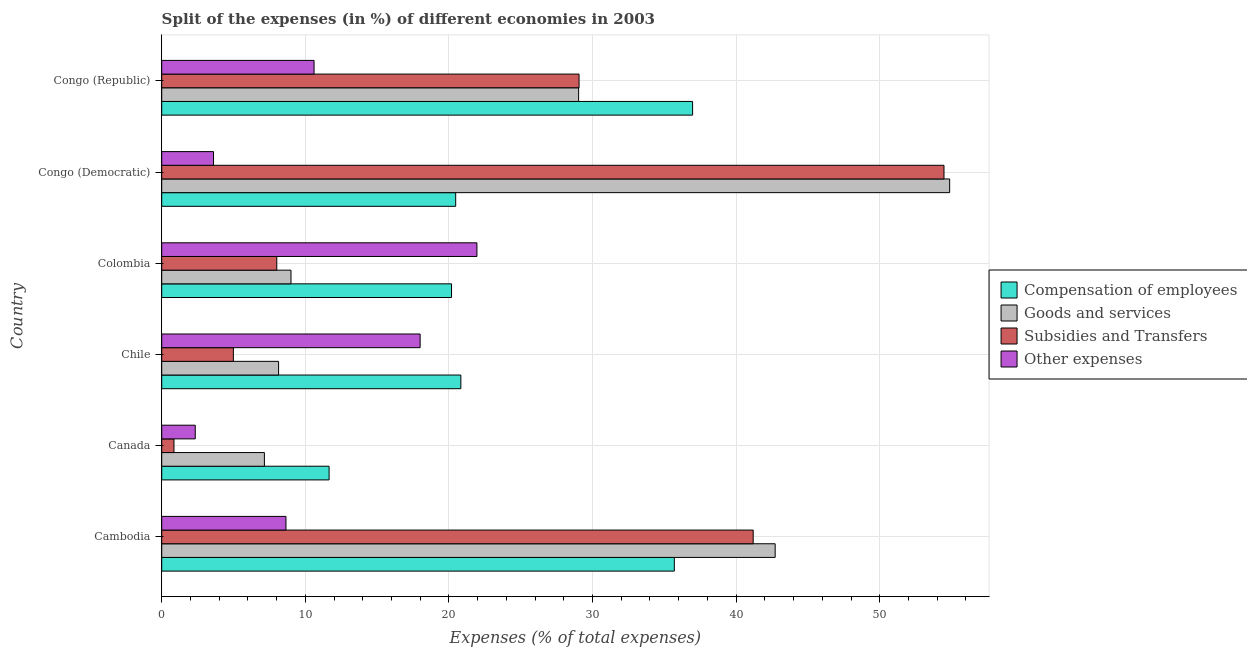How many different coloured bars are there?
Your answer should be compact. 4. How many groups of bars are there?
Give a very brief answer. 6. What is the label of the 4th group of bars from the top?
Make the answer very short. Chile. In how many cases, is the number of bars for a given country not equal to the number of legend labels?
Your answer should be compact. 0. What is the percentage of amount spent on compensation of employees in Colombia?
Keep it short and to the point. 20.18. Across all countries, what is the maximum percentage of amount spent on goods and services?
Make the answer very short. 54.87. Across all countries, what is the minimum percentage of amount spent on goods and services?
Make the answer very short. 7.15. In which country was the percentage of amount spent on subsidies maximum?
Offer a very short reply. Congo (Democratic). What is the total percentage of amount spent on goods and services in the graph?
Your answer should be compact. 150.91. What is the difference between the percentage of amount spent on goods and services in Cambodia and that in Canada?
Give a very brief answer. 35.57. What is the difference between the percentage of amount spent on subsidies in Canada and the percentage of amount spent on other expenses in Cambodia?
Your answer should be very brief. -7.8. What is the average percentage of amount spent on compensation of employees per country?
Make the answer very short. 24.3. What is the difference between the percentage of amount spent on other expenses and percentage of amount spent on subsidies in Cambodia?
Provide a short and direct response. -32.53. What is the ratio of the percentage of amount spent on goods and services in Chile to that in Congo (Democratic)?
Your answer should be very brief. 0.15. Is the percentage of amount spent on subsidies in Cambodia less than that in Canada?
Provide a short and direct response. No. Is the difference between the percentage of amount spent on subsidies in Chile and Congo (Democratic) greater than the difference between the percentage of amount spent on goods and services in Chile and Congo (Democratic)?
Offer a very short reply. No. What is the difference between the highest and the second highest percentage of amount spent on goods and services?
Make the answer very short. 12.15. What is the difference between the highest and the lowest percentage of amount spent on subsidies?
Your response must be concise. 53.62. In how many countries, is the percentage of amount spent on compensation of employees greater than the average percentage of amount spent on compensation of employees taken over all countries?
Give a very brief answer. 2. What does the 3rd bar from the top in Canada represents?
Make the answer very short. Goods and services. What does the 1st bar from the bottom in Cambodia represents?
Ensure brevity in your answer.  Compensation of employees. Is it the case that in every country, the sum of the percentage of amount spent on compensation of employees and percentage of amount spent on goods and services is greater than the percentage of amount spent on subsidies?
Give a very brief answer. Yes. How many countries are there in the graph?
Offer a very short reply. 6. Are the values on the major ticks of X-axis written in scientific E-notation?
Your answer should be compact. No. Does the graph contain any zero values?
Ensure brevity in your answer.  No. Does the graph contain grids?
Offer a very short reply. Yes. Where does the legend appear in the graph?
Offer a very short reply. Center right. How are the legend labels stacked?
Your answer should be compact. Vertical. What is the title of the graph?
Keep it short and to the point. Split of the expenses (in %) of different economies in 2003. What is the label or title of the X-axis?
Keep it short and to the point. Expenses (% of total expenses). What is the label or title of the Y-axis?
Offer a very short reply. Country. What is the Expenses (% of total expenses) in Compensation of employees in Cambodia?
Give a very brief answer. 35.7. What is the Expenses (% of total expenses) in Goods and services in Cambodia?
Your answer should be compact. 42.72. What is the Expenses (% of total expenses) in Subsidies and Transfers in Cambodia?
Keep it short and to the point. 41.19. What is the Expenses (% of total expenses) of Other expenses in Cambodia?
Ensure brevity in your answer.  8.65. What is the Expenses (% of total expenses) of Compensation of employees in Canada?
Your response must be concise. 11.66. What is the Expenses (% of total expenses) in Goods and services in Canada?
Offer a terse response. 7.15. What is the Expenses (% of total expenses) in Subsidies and Transfers in Canada?
Your response must be concise. 0.85. What is the Expenses (% of total expenses) of Other expenses in Canada?
Give a very brief answer. 2.34. What is the Expenses (% of total expenses) in Compensation of employees in Chile?
Make the answer very short. 20.83. What is the Expenses (% of total expenses) in Goods and services in Chile?
Ensure brevity in your answer.  8.14. What is the Expenses (% of total expenses) in Subsidies and Transfers in Chile?
Keep it short and to the point. 4.99. What is the Expenses (% of total expenses) of Other expenses in Chile?
Your response must be concise. 17.99. What is the Expenses (% of total expenses) of Compensation of employees in Colombia?
Offer a very short reply. 20.18. What is the Expenses (% of total expenses) of Goods and services in Colombia?
Make the answer very short. 9. What is the Expenses (% of total expenses) in Subsidies and Transfers in Colombia?
Your response must be concise. 8.01. What is the Expenses (% of total expenses) of Other expenses in Colombia?
Keep it short and to the point. 21.95. What is the Expenses (% of total expenses) of Compensation of employees in Congo (Democratic)?
Offer a terse response. 20.47. What is the Expenses (% of total expenses) in Goods and services in Congo (Democratic)?
Make the answer very short. 54.87. What is the Expenses (% of total expenses) of Subsidies and Transfers in Congo (Democratic)?
Ensure brevity in your answer.  54.47. What is the Expenses (% of total expenses) of Other expenses in Congo (Democratic)?
Provide a succinct answer. 3.61. What is the Expenses (% of total expenses) in Compensation of employees in Congo (Republic)?
Provide a short and direct response. 36.97. What is the Expenses (% of total expenses) in Goods and services in Congo (Republic)?
Offer a terse response. 29.03. What is the Expenses (% of total expenses) in Subsidies and Transfers in Congo (Republic)?
Make the answer very short. 29.06. What is the Expenses (% of total expenses) of Other expenses in Congo (Republic)?
Provide a succinct answer. 10.61. Across all countries, what is the maximum Expenses (% of total expenses) in Compensation of employees?
Your answer should be very brief. 36.97. Across all countries, what is the maximum Expenses (% of total expenses) of Goods and services?
Offer a very short reply. 54.87. Across all countries, what is the maximum Expenses (% of total expenses) in Subsidies and Transfers?
Offer a terse response. 54.47. Across all countries, what is the maximum Expenses (% of total expenses) in Other expenses?
Make the answer very short. 21.95. Across all countries, what is the minimum Expenses (% of total expenses) of Compensation of employees?
Provide a short and direct response. 11.66. Across all countries, what is the minimum Expenses (% of total expenses) in Goods and services?
Ensure brevity in your answer.  7.15. Across all countries, what is the minimum Expenses (% of total expenses) in Subsidies and Transfers?
Provide a short and direct response. 0.85. Across all countries, what is the minimum Expenses (% of total expenses) of Other expenses?
Make the answer very short. 2.34. What is the total Expenses (% of total expenses) in Compensation of employees in the graph?
Provide a succinct answer. 145.8. What is the total Expenses (% of total expenses) of Goods and services in the graph?
Provide a short and direct response. 150.91. What is the total Expenses (% of total expenses) of Subsidies and Transfers in the graph?
Offer a very short reply. 138.58. What is the total Expenses (% of total expenses) in Other expenses in the graph?
Your answer should be compact. 65.15. What is the difference between the Expenses (% of total expenses) of Compensation of employees in Cambodia and that in Canada?
Offer a terse response. 24.04. What is the difference between the Expenses (% of total expenses) of Goods and services in Cambodia and that in Canada?
Keep it short and to the point. 35.57. What is the difference between the Expenses (% of total expenses) in Subsidies and Transfers in Cambodia and that in Canada?
Offer a terse response. 40.33. What is the difference between the Expenses (% of total expenses) of Other expenses in Cambodia and that in Canada?
Offer a terse response. 6.32. What is the difference between the Expenses (% of total expenses) in Compensation of employees in Cambodia and that in Chile?
Make the answer very short. 14.87. What is the difference between the Expenses (% of total expenses) in Goods and services in Cambodia and that in Chile?
Offer a very short reply. 34.58. What is the difference between the Expenses (% of total expenses) of Subsidies and Transfers in Cambodia and that in Chile?
Offer a terse response. 36.2. What is the difference between the Expenses (% of total expenses) in Other expenses in Cambodia and that in Chile?
Give a very brief answer. -9.34. What is the difference between the Expenses (% of total expenses) of Compensation of employees in Cambodia and that in Colombia?
Provide a succinct answer. 15.51. What is the difference between the Expenses (% of total expenses) of Goods and services in Cambodia and that in Colombia?
Make the answer very short. 33.72. What is the difference between the Expenses (% of total expenses) in Subsidies and Transfers in Cambodia and that in Colombia?
Offer a very short reply. 33.17. What is the difference between the Expenses (% of total expenses) of Other expenses in Cambodia and that in Colombia?
Your response must be concise. -13.3. What is the difference between the Expenses (% of total expenses) of Compensation of employees in Cambodia and that in Congo (Democratic)?
Ensure brevity in your answer.  15.22. What is the difference between the Expenses (% of total expenses) in Goods and services in Cambodia and that in Congo (Democratic)?
Offer a very short reply. -12.15. What is the difference between the Expenses (% of total expenses) in Subsidies and Transfers in Cambodia and that in Congo (Democratic)?
Provide a succinct answer. -13.29. What is the difference between the Expenses (% of total expenses) in Other expenses in Cambodia and that in Congo (Democratic)?
Make the answer very short. 5.04. What is the difference between the Expenses (% of total expenses) in Compensation of employees in Cambodia and that in Congo (Republic)?
Your answer should be very brief. -1.27. What is the difference between the Expenses (% of total expenses) of Goods and services in Cambodia and that in Congo (Republic)?
Provide a short and direct response. 13.69. What is the difference between the Expenses (% of total expenses) in Subsidies and Transfers in Cambodia and that in Congo (Republic)?
Your answer should be compact. 12.13. What is the difference between the Expenses (% of total expenses) in Other expenses in Cambodia and that in Congo (Republic)?
Offer a terse response. -1.96. What is the difference between the Expenses (% of total expenses) of Compensation of employees in Canada and that in Chile?
Provide a short and direct response. -9.17. What is the difference between the Expenses (% of total expenses) in Goods and services in Canada and that in Chile?
Your answer should be very brief. -0.99. What is the difference between the Expenses (% of total expenses) of Subsidies and Transfers in Canada and that in Chile?
Your answer should be very brief. -4.14. What is the difference between the Expenses (% of total expenses) in Other expenses in Canada and that in Chile?
Offer a very short reply. -15.66. What is the difference between the Expenses (% of total expenses) of Compensation of employees in Canada and that in Colombia?
Your answer should be very brief. -8.53. What is the difference between the Expenses (% of total expenses) in Goods and services in Canada and that in Colombia?
Provide a short and direct response. -1.85. What is the difference between the Expenses (% of total expenses) in Subsidies and Transfers in Canada and that in Colombia?
Provide a short and direct response. -7.16. What is the difference between the Expenses (% of total expenses) of Other expenses in Canada and that in Colombia?
Provide a short and direct response. -19.61. What is the difference between the Expenses (% of total expenses) of Compensation of employees in Canada and that in Congo (Democratic)?
Provide a short and direct response. -8.82. What is the difference between the Expenses (% of total expenses) in Goods and services in Canada and that in Congo (Democratic)?
Give a very brief answer. -47.72. What is the difference between the Expenses (% of total expenses) of Subsidies and Transfers in Canada and that in Congo (Democratic)?
Make the answer very short. -53.62. What is the difference between the Expenses (% of total expenses) in Other expenses in Canada and that in Congo (Democratic)?
Keep it short and to the point. -1.27. What is the difference between the Expenses (% of total expenses) of Compensation of employees in Canada and that in Congo (Republic)?
Keep it short and to the point. -25.31. What is the difference between the Expenses (% of total expenses) in Goods and services in Canada and that in Congo (Republic)?
Offer a terse response. -21.88. What is the difference between the Expenses (% of total expenses) of Subsidies and Transfers in Canada and that in Congo (Republic)?
Provide a succinct answer. -28.21. What is the difference between the Expenses (% of total expenses) in Other expenses in Canada and that in Congo (Republic)?
Provide a short and direct response. -8.27. What is the difference between the Expenses (% of total expenses) of Compensation of employees in Chile and that in Colombia?
Your answer should be compact. 0.65. What is the difference between the Expenses (% of total expenses) of Goods and services in Chile and that in Colombia?
Give a very brief answer. -0.86. What is the difference between the Expenses (% of total expenses) of Subsidies and Transfers in Chile and that in Colombia?
Your answer should be very brief. -3.02. What is the difference between the Expenses (% of total expenses) of Other expenses in Chile and that in Colombia?
Give a very brief answer. -3.96. What is the difference between the Expenses (% of total expenses) in Compensation of employees in Chile and that in Congo (Democratic)?
Provide a short and direct response. 0.36. What is the difference between the Expenses (% of total expenses) of Goods and services in Chile and that in Congo (Democratic)?
Offer a very short reply. -46.73. What is the difference between the Expenses (% of total expenses) in Subsidies and Transfers in Chile and that in Congo (Democratic)?
Provide a short and direct response. -49.49. What is the difference between the Expenses (% of total expenses) in Other expenses in Chile and that in Congo (Democratic)?
Offer a very short reply. 14.39. What is the difference between the Expenses (% of total expenses) in Compensation of employees in Chile and that in Congo (Republic)?
Make the answer very short. -16.14. What is the difference between the Expenses (% of total expenses) in Goods and services in Chile and that in Congo (Republic)?
Make the answer very short. -20.89. What is the difference between the Expenses (% of total expenses) in Subsidies and Transfers in Chile and that in Congo (Republic)?
Your response must be concise. -24.07. What is the difference between the Expenses (% of total expenses) of Other expenses in Chile and that in Congo (Republic)?
Keep it short and to the point. 7.39. What is the difference between the Expenses (% of total expenses) in Compensation of employees in Colombia and that in Congo (Democratic)?
Keep it short and to the point. -0.29. What is the difference between the Expenses (% of total expenses) in Goods and services in Colombia and that in Congo (Democratic)?
Provide a short and direct response. -45.87. What is the difference between the Expenses (% of total expenses) of Subsidies and Transfers in Colombia and that in Congo (Democratic)?
Your answer should be very brief. -46.46. What is the difference between the Expenses (% of total expenses) of Other expenses in Colombia and that in Congo (Democratic)?
Provide a short and direct response. 18.34. What is the difference between the Expenses (% of total expenses) in Compensation of employees in Colombia and that in Congo (Republic)?
Provide a succinct answer. -16.79. What is the difference between the Expenses (% of total expenses) of Goods and services in Colombia and that in Congo (Republic)?
Your response must be concise. -20.03. What is the difference between the Expenses (% of total expenses) of Subsidies and Transfers in Colombia and that in Congo (Republic)?
Give a very brief answer. -21.05. What is the difference between the Expenses (% of total expenses) of Other expenses in Colombia and that in Congo (Republic)?
Provide a succinct answer. 11.34. What is the difference between the Expenses (% of total expenses) in Compensation of employees in Congo (Democratic) and that in Congo (Republic)?
Provide a short and direct response. -16.5. What is the difference between the Expenses (% of total expenses) in Goods and services in Congo (Democratic) and that in Congo (Republic)?
Your answer should be very brief. 25.84. What is the difference between the Expenses (% of total expenses) in Subsidies and Transfers in Congo (Democratic) and that in Congo (Republic)?
Your answer should be very brief. 25.41. What is the difference between the Expenses (% of total expenses) of Other expenses in Congo (Democratic) and that in Congo (Republic)?
Keep it short and to the point. -7. What is the difference between the Expenses (% of total expenses) in Compensation of employees in Cambodia and the Expenses (% of total expenses) in Goods and services in Canada?
Offer a terse response. 28.54. What is the difference between the Expenses (% of total expenses) of Compensation of employees in Cambodia and the Expenses (% of total expenses) of Subsidies and Transfers in Canada?
Your answer should be very brief. 34.84. What is the difference between the Expenses (% of total expenses) in Compensation of employees in Cambodia and the Expenses (% of total expenses) in Other expenses in Canada?
Offer a terse response. 33.36. What is the difference between the Expenses (% of total expenses) in Goods and services in Cambodia and the Expenses (% of total expenses) in Subsidies and Transfers in Canada?
Make the answer very short. 41.86. What is the difference between the Expenses (% of total expenses) of Goods and services in Cambodia and the Expenses (% of total expenses) of Other expenses in Canada?
Offer a very short reply. 40.38. What is the difference between the Expenses (% of total expenses) in Subsidies and Transfers in Cambodia and the Expenses (% of total expenses) in Other expenses in Canada?
Keep it short and to the point. 38.85. What is the difference between the Expenses (% of total expenses) of Compensation of employees in Cambodia and the Expenses (% of total expenses) of Goods and services in Chile?
Your response must be concise. 27.56. What is the difference between the Expenses (% of total expenses) in Compensation of employees in Cambodia and the Expenses (% of total expenses) in Subsidies and Transfers in Chile?
Make the answer very short. 30.71. What is the difference between the Expenses (% of total expenses) of Compensation of employees in Cambodia and the Expenses (% of total expenses) of Other expenses in Chile?
Offer a very short reply. 17.7. What is the difference between the Expenses (% of total expenses) in Goods and services in Cambodia and the Expenses (% of total expenses) in Subsidies and Transfers in Chile?
Your answer should be very brief. 37.73. What is the difference between the Expenses (% of total expenses) in Goods and services in Cambodia and the Expenses (% of total expenses) in Other expenses in Chile?
Your answer should be very brief. 24.72. What is the difference between the Expenses (% of total expenses) of Subsidies and Transfers in Cambodia and the Expenses (% of total expenses) of Other expenses in Chile?
Keep it short and to the point. 23.19. What is the difference between the Expenses (% of total expenses) of Compensation of employees in Cambodia and the Expenses (% of total expenses) of Goods and services in Colombia?
Give a very brief answer. 26.69. What is the difference between the Expenses (% of total expenses) in Compensation of employees in Cambodia and the Expenses (% of total expenses) in Subsidies and Transfers in Colombia?
Give a very brief answer. 27.68. What is the difference between the Expenses (% of total expenses) in Compensation of employees in Cambodia and the Expenses (% of total expenses) in Other expenses in Colombia?
Make the answer very short. 13.75. What is the difference between the Expenses (% of total expenses) in Goods and services in Cambodia and the Expenses (% of total expenses) in Subsidies and Transfers in Colombia?
Your response must be concise. 34.71. What is the difference between the Expenses (% of total expenses) of Goods and services in Cambodia and the Expenses (% of total expenses) of Other expenses in Colombia?
Give a very brief answer. 20.77. What is the difference between the Expenses (% of total expenses) in Subsidies and Transfers in Cambodia and the Expenses (% of total expenses) in Other expenses in Colombia?
Your answer should be compact. 19.24. What is the difference between the Expenses (% of total expenses) of Compensation of employees in Cambodia and the Expenses (% of total expenses) of Goods and services in Congo (Democratic)?
Give a very brief answer. -19.17. What is the difference between the Expenses (% of total expenses) of Compensation of employees in Cambodia and the Expenses (% of total expenses) of Subsidies and Transfers in Congo (Democratic)?
Ensure brevity in your answer.  -18.78. What is the difference between the Expenses (% of total expenses) in Compensation of employees in Cambodia and the Expenses (% of total expenses) in Other expenses in Congo (Democratic)?
Offer a terse response. 32.09. What is the difference between the Expenses (% of total expenses) in Goods and services in Cambodia and the Expenses (% of total expenses) in Subsidies and Transfers in Congo (Democratic)?
Offer a terse response. -11.76. What is the difference between the Expenses (% of total expenses) of Goods and services in Cambodia and the Expenses (% of total expenses) of Other expenses in Congo (Democratic)?
Provide a short and direct response. 39.11. What is the difference between the Expenses (% of total expenses) of Subsidies and Transfers in Cambodia and the Expenses (% of total expenses) of Other expenses in Congo (Democratic)?
Your response must be concise. 37.58. What is the difference between the Expenses (% of total expenses) of Compensation of employees in Cambodia and the Expenses (% of total expenses) of Goods and services in Congo (Republic)?
Offer a terse response. 6.66. What is the difference between the Expenses (% of total expenses) in Compensation of employees in Cambodia and the Expenses (% of total expenses) in Subsidies and Transfers in Congo (Republic)?
Provide a short and direct response. 6.63. What is the difference between the Expenses (% of total expenses) of Compensation of employees in Cambodia and the Expenses (% of total expenses) of Other expenses in Congo (Republic)?
Ensure brevity in your answer.  25.09. What is the difference between the Expenses (% of total expenses) in Goods and services in Cambodia and the Expenses (% of total expenses) in Subsidies and Transfers in Congo (Republic)?
Your response must be concise. 13.66. What is the difference between the Expenses (% of total expenses) of Goods and services in Cambodia and the Expenses (% of total expenses) of Other expenses in Congo (Republic)?
Your answer should be compact. 32.11. What is the difference between the Expenses (% of total expenses) of Subsidies and Transfers in Cambodia and the Expenses (% of total expenses) of Other expenses in Congo (Republic)?
Make the answer very short. 30.58. What is the difference between the Expenses (% of total expenses) of Compensation of employees in Canada and the Expenses (% of total expenses) of Goods and services in Chile?
Give a very brief answer. 3.52. What is the difference between the Expenses (% of total expenses) of Compensation of employees in Canada and the Expenses (% of total expenses) of Subsidies and Transfers in Chile?
Ensure brevity in your answer.  6.67. What is the difference between the Expenses (% of total expenses) in Compensation of employees in Canada and the Expenses (% of total expenses) in Other expenses in Chile?
Give a very brief answer. -6.34. What is the difference between the Expenses (% of total expenses) of Goods and services in Canada and the Expenses (% of total expenses) of Subsidies and Transfers in Chile?
Offer a terse response. 2.16. What is the difference between the Expenses (% of total expenses) in Goods and services in Canada and the Expenses (% of total expenses) in Other expenses in Chile?
Ensure brevity in your answer.  -10.84. What is the difference between the Expenses (% of total expenses) of Subsidies and Transfers in Canada and the Expenses (% of total expenses) of Other expenses in Chile?
Keep it short and to the point. -17.14. What is the difference between the Expenses (% of total expenses) of Compensation of employees in Canada and the Expenses (% of total expenses) of Goods and services in Colombia?
Provide a succinct answer. 2.65. What is the difference between the Expenses (% of total expenses) in Compensation of employees in Canada and the Expenses (% of total expenses) in Subsidies and Transfers in Colombia?
Keep it short and to the point. 3.64. What is the difference between the Expenses (% of total expenses) of Compensation of employees in Canada and the Expenses (% of total expenses) of Other expenses in Colombia?
Provide a succinct answer. -10.29. What is the difference between the Expenses (% of total expenses) in Goods and services in Canada and the Expenses (% of total expenses) in Subsidies and Transfers in Colombia?
Provide a succinct answer. -0.86. What is the difference between the Expenses (% of total expenses) of Goods and services in Canada and the Expenses (% of total expenses) of Other expenses in Colombia?
Give a very brief answer. -14.8. What is the difference between the Expenses (% of total expenses) in Subsidies and Transfers in Canada and the Expenses (% of total expenses) in Other expenses in Colombia?
Give a very brief answer. -21.1. What is the difference between the Expenses (% of total expenses) in Compensation of employees in Canada and the Expenses (% of total expenses) in Goods and services in Congo (Democratic)?
Ensure brevity in your answer.  -43.21. What is the difference between the Expenses (% of total expenses) in Compensation of employees in Canada and the Expenses (% of total expenses) in Subsidies and Transfers in Congo (Democratic)?
Keep it short and to the point. -42.82. What is the difference between the Expenses (% of total expenses) in Compensation of employees in Canada and the Expenses (% of total expenses) in Other expenses in Congo (Democratic)?
Your response must be concise. 8.05. What is the difference between the Expenses (% of total expenses) of Goods and services in Canada and the Expenses (% of total expenses) of Subsidies and Transfers in Congo (Democratic)?
Provide a succinct answer. -47.32. What is the difference between the Expenses (% of total expenses) of Goods and services in Canada and the Expenses (% of total expenses) of Other expenses in Congo (Democratic)?
Provide a short and direct response. 3.54. What is the difference between the Expenses (% of total expenses) in Subsidies and Transfers in Canada and the Expenses (% of total expenses) in Other expenses in Congo (Democratic)?
Offer a very short reply. -2.76. What is the difference between the Expenses (% of total expenses) of Compensation of employees in Canada and the Expenses (% of total expenses) of Goods and services in Congo (Republic)?
Provide a short and direct response. -17.38. What is the difference between the Expenses (% of total expenses) of Compensation of employees in Canada and the Expenses (% of total expenses) of Subsidies and Transfers in Congo (Republic)?
Offer a very short reply. -17.41. What is the difference between the Expenses (% of total expenses) of Compensation of employees in Canada and the Expenses (% of total expenses) of Other expenses in Congo (Republic)?
Offer a very short reply. 1.05. What is the difference between the Expenses (% of total expenses) of Goods and services in Canada and the Expenses (% of total expenses) of Subsidies and Transfers in Congo (Republic)?
Your answer should be compact. -21.91. What is the difference between the Expenses (% of total expenses) of Goods and services in Canada and the Expenses (% of total expenses) of Other expenses in Congo (Republic)?
Provide a short and direct response. -3.46. What is the difference between the Expenses (% of total expenses) of Subsidies and Transfers in Canada and the Expenses (% of total expenses) of Other expenses in Congo (Republic)?
Make the answer very short. -9.76. What is the difference between the Expenses (% of total expenses) of Compensation of employees in Chile and the Expenses (% of total expenses) of Goods and services in Colombia?
Provide a short and direct response. 11.83. What is the difference between the Expenses (% of total expenses) in Compensation of employees in Chile and the Expenses (% of total expenses) in Subsidies and Transfers in Colombia?
Your response must be concise. 12.82. What is the difference between the Expenses (% of total expenses) of Compensation of employees in Chile and the Expenses (% of total expenses) of Other expenses in Colombia?
Give a very brief answer. -1.12. What is the difference between the Expenses (% of total expenses) in Goods and services in Chile and the Expenses (% of total expenses) in Subsidies and Transfers in Colombia?
Your answer should be compact. 0.13. What is the difference between the Expenses (% of total expenses) of Goods and services in Chile and the Expenses (% of total expenses) of Other expenses in Colombia?
Your answer should be very brief. -13.81. What is the difference between the Expenses (% of total expenses) of Subsidies and Transfers in Chile and the Expenses (% of total expenses) of Other expenses in Colombia?
Provide a short and direct response. -16.96. What is the difference between the Expenses (% of total expenses) in Compensation of employees in Chile and the Expenses (% of total expenses) in Goods and services in Congo (Democratic)?
Provide a succinct answer. -34.04. What is the difference between the Expenses (% of total expenses) in Compensation of employees in Chile and the Expenses (% of total expenses) in Subsidies and Transfers in Congo (Democratic)?
Provide a succinct answer. -33.64. What is the difference between the Expenses (% of total expenses) of Compensation of employees in Chile and the Expenses (% of total expenses) of Other expenses in Congo (Democratic)?
Give a very brief answer. 17.22. What is the difference between the Expenses (% of total expenses) in Goods and services in Chile and the Expenses (% of total expenses) in Subsidies and Transfers in Congo (Democratic)?
Offer a very short reply. -46.34. What is the difference between the Expenses (% of total expenses) in Goods and services in Chile and the Expenses (% of total expenses) in Other expenses in Congo (Democratic)?
Give a very brief answer. 4.53. What is the difference between the Expenses (% of total expenses) in Subsidies and Transfers in Chile and the Expenses (% of total expenses) in Other expenses in Congo (Democratic)?
Give a very brief answer. 1.38. What is the difference between the Expenses (% of total expenses) in Compensation of employees in Chile and the Expenses (% of total expenses) in Goods and services in Congo (Republic)?
Ensure brevity in your answer.  -8.2. What is the difference between the Expenses (% of total expenses) of Compensation of employees in Chile and the Expenses (% of total expenses) of Subsidies and Transfers in Congo (Republic)?
Offer a very short reply. -8.23. What is the difference between the Expenses (% of total expenses) in Compensation of employees in Chile and the Expenses (% of total expenses) in Other expenses in Congo (Republic)?
Provide a short and direct response. 10.22. What is the difference between the Expenses (% of total expenses) in Goods and services in Chile and the Expenses (% of total expenses) in Subsidies and Transfers in Congo (Republic)?
Offer a terse response. -20.92. What is the difference between the Expenses (% of total expenses) of Goods and services in Chile and the Expenses (% of total expenses) of Other expenses in Congo (Republic)?
Offer a terse response. -2.47. What is the difference between the Expenses (% of total expenses) of Subsidies and Transfers in Chile and the Expenses (% of total expenses) of Other expenses in Congo (Republic)?
Ensure brevity in your answer.  -5.62. What is the difference between the Expenses (% of total expenses) in Compensation of employees in Colombia and the Expenses (% of total expenses) in Goods and services in Congo (Democratic)?
Your answer should be compact. -34.69. What is the difference between the Expenses (% of total expenses) in Compensation of employees in Colombia and the Expenses (% of total expenses) in Subsidies and Transfers in Congo (Democratic)?
Your answer should be very brief. -34.29. What is the difference between the Expenses (% of total expenses) of Compensation of employees in Colombia and the Expenses (% of total expenses) of Other expenses in Congo (Democratic)?
Offer a terse response. 16.57. What is the difference between the Expenses (% of total expenses) in Goods and services in Colombia and the Expenses (% of total expenses) in Subsidies and Transfers in Congo (Democratic)?
Your answer should be very brief. -45.47. What is the difference between the Expenses (% of total expenses) of Goods and services in Colombia and the Expenses (% of total expenses) of Other expenses in Congo (Democratic)?
Make the answer very short. 5.39. What is the difference between the Expenses (% of total expenses) of Subsidies and Transfers in Colombia and the Expenses (% of total expenses) of Other expenses in Congo (Democratic)?
Ensure brevity in your answer.  4.4. What is the difference between the Expenses (% of total expenses) in Compensation of employees in Colombia and the Expenses (% of total expenses) in Goods and services in Congo (Republic)?
Give a very brief answer. -8.85. What is the difference between the Expenses (% of total expenses) of Compensation of employees in Colombia and the Expenses (% of total expenses) of Subsidies and Transfers in Congo (Republic)?
Your answer should be compact. -8.88. What is the difference between the Expenses (% of total expenses) of Compensation of employees in Colombia and the Expenses (% of total expenses) of Other expenses in Congo (Republic)?
Your answer should be compact. 9.57. What is the difference between the Expenses (% of total expenses) of Goods and services in Colombia and the Expenses (% of total expenses) of Subsidies and Transfers in Congo (Republic)?
Your answer should be very brief. -20.06. What is the difference between the Expenses (% of total expenses) in Goods and services in Colombia and the Expenses (% of total expenses) in Other expenses in Congo (Republic)?
Give a very brief answer. -1.61. What is the difference between the Expenses (% of total expenses) of Subsidies and Transfers in Colombia and the Expenses (% of total expenses) of Other expenses in Congo (Republic)?
Give a very brief answer. -2.6. What is the difference between the Expenses (% of total expenses) in Compensation of employees in Congo (Democratic) and the Expenses (% of total expenses) in Goods and services in Congo (Republic)?
Offer a very short reply. -8.56. What is the difference between the Expenses (% of total expenses) of Compensation of employees in Congo (Democratic) and the Expenses (% of total expenses) of Subsidies and Transfers in Congo (Republic)?
Your answer should be compact. -8.59. What is the difference between the Expenses (% of total expenses) in Compensation of employees in Congo (Democratic) and the Expenses (% of total expenses) in Other expenses in Congo (Republic)?
Provide a succinct answer. 9.86. What is the difference between the Expenses (% of total expenses) in Goods and services in Congo (Democratic) and the Expenses (% of total expenses) in Subsidies and Transfers in Congo (Republic)?
Offer a very short reply. 25.81. What is the difference between the Expenses (% of total expenses) of Goods and services in Congo (Democratic) and the Expenses (% of total expenses) of Other expenses in Congo (Republic)?
Keep it short and to the point. 44.26. What is the difference between the Expenses (% of total expenses) in Subsidies and Transfers in Congo (Democratic) and the Expenses (% of total expenses) in Other expenses in Congo (Republic)?
Offer a terse response. 43.87. What is the average Expenses (% of total expenses) of Compensation of employees per country?
Your answer should be compact. 24.3. What is the average Expenses (% of total expenses) of Goods and services per country?
Ensure brevity in your answer.  25.15. What is the average Expenses (% of total expenses) of Subsidies and Transfers per country?
Your answer should be very brief. 23.1. What is the average Expenses (% of total expenses) of Other expenses per country?
Make the answer very short. 10.86. What is the difference between the Expenses (% of total expenses) of Compensation of employees and Expenses (% of total expenses) of Goods and services in Cambodia?
Keep it short and to the point. -7.02. What is the difference between the Expenses (% of total expenses) of Compensation of employees and Expenses (% of total expenses) of Subsidies and Transfers in Cambodia?
Give a very brief answer. -5.49. What is the difference between the Expenses (% of total expenses) in Compensation of employees and Expenses (% of total expenses) in Other expenses in Cambodia?
Offer a terse response. 27.04. What is the difference between the Expenses (% of total expenses) in Goods and services and Expenses (% of total expenses) in Subsidies and Transfers in Cambodia?
Provide a succinct answer. 1.53. What is the difference between the Expenses (% of total expenses) of Goods and services and Expenses (% of total expenses) of Other expenses in Cambodia?
Give a very brief answer. 34.07. What is the difference between the Expenses (% of total expenses) in Subsidies and Transfers and Expenses (% of total expenses) in Other expenses in Cambodia?
Provide a short and direct response. 32.53. What is the difference between the Expenses (% of total expenses) of Compensation of employees and Expenses (% of total expenses) of Goods and services in Canada?
Give a very brief answer. 4.5. What is the difference between the Expenses (% of total expenses) of Compensation of employees and Expenses (% of total expenses) of Subsidies and Transfers in Canada?
Give a very brief answer. 10.8. What is the difference between the Expenses (% of total expenses) in Compensation of employees and Expenses (% of total expenses) in Other expenses in Canada?
Keep it short and to the point. 9.32. What is the difference between the Expenses (% of total expenses) in Goods and services and Expenses (% of total expenses) in Subsidies and Transfers in Canada?
Keep it short and to the point. 6.3. What is the difference between the Expenses (% of total expenses) in Goods and services and Expenses (% of total expenses) in Other expenses in Canada?
Provide a succinct answer. 4.81. What is the difference between the Expenses (% of total expenses) in Subsidies and Transfers and Expenses (% of total expenses) in Other expenses in Canada?
Provide a short and direct response. -1.48. What is the difference between the Expenses (% of total expenses) in Compensation of employees and Expenses (% of total expenses) in Goods and services in Chile?
Your response must be concise. 12.69. What is the difference between the Expenses (% of total expenses) in Compensation of employees and Expenses (% of total expenses) in Subsidies and Transfers in Chile?
Offer a very short reply. 15.84. What is the difference between the Expenses (% of total expenses) of Compensation of employees and Expenses (% of total expenses) of Other expenses in Chile?
Make the answer very short. 2.84. What is the difference between the Expenses (% of total expenses) of Goods and services and Expenses (% of total expenses) of Subsidies and Transfers in Chile?
Provide a succinct answer. 3.15. What is the difference between the Expenses (% of total expenses) of Goods and services and Expenses (% of total expenses) of Other expenses in Chile?
Give a very brief answer. -9.86. What is the difference between the Expenses (% of total expenses) of Subsidies and Transfers and Expenses (% of total expenses) of Other expenses in Chile?
Give a very brief answer. -13.01. What is the difference between the Expenses (% of total expenses) of Compensation of employees and Expenses (% of total expenses) of Goods and services in Colombia?
Make the answer very short. 11.18. What is the difference between the Expenses (% of total expenses) in Compensation of employees and Expenses (% of total expenses) in Subsidies and Transfers in Colombia?
Your answer should be very brief. 12.17. What is the difference between the Expenses (% of total expenses) of Compensation of employees and Expenses (% of total expenses) of Other expenses in Colombia?
Ensure brevity in your answer.  -1.77. What is the difference between the Expenses (% of total expenses) in Goods and services and Expenses (% of total expenses) in Other expenses in Colombia?
Ensure brevity in your answer.  -12.95. What is the difference between the Expenses (% of total expenses) in Subsidies and Transfers and Expenses (% of total expenses) in Other expenses in Colombia?
Make the answer very short. -13.94. What is the difference between the Expenses (% of total expenses) in Compensation of employees and Expenses (% of total expenses) in Goods and services in Congo (Democratic)?
Offer a terse response. -34.4. What is the difference between the Expenses (% of total expenses) in Compensation of employees and Expenses (% of total expenses) in Subsidies and Transfers in Congo (Democratic)?
Provide a short and direct response. -34. What is the difference between the Expenses (% of total expenses) in Compensation of employees and Expenses (% of total expenses) in Other expenses in Congo (Democratic)?
Provide a succinct answer. 16.86. What is the difference between the Expenses (% of total expenses) of Goods and services and Expenses (% of total expenses) of Subsidies and Transfers in Congo (Democratic)?
Keep it short and to the point. 0.39. What is the difference between the Expenses (% of total expenses) of Goods and services and Expenses (% of total expenses) of Other expenses in Congo (Democratic)?
Ensure brevity in your answer.  51.26. What is the difference between the Expenses (% of total expenses) of Subsidies and Transfers and Expenses (% of total expenses) of Other expenses in Congo (Democratic)?
Your answer should be very brief. 50.87. What is the difference between the Expenses (% of total expenses) in Compensation of employees and Expenses (% of total expenses) in Goods and services in Congo (Republic)?
Your answer should be compact. 7.94. What is the difference between the Expenses (% of total expenses) of Compensation of employees and Expenses (% of total expenses) of Subsidies and Transfers in Congo (Republic)?
Your answer should be compact. 7.91. What is the difference between the Expenses (% of total expenses) of Compensation of employees and Expenses (% of total expenses) of Other expenses in Congo (Republic)?
Provide a succinct answer. 26.36. What is the difference between the Expenses (% of total expenses) of Goods and services and Expenses (% of total expenses) of Subsidies and Transfers in Congo (Republic)?
Provide a succinct answer. -0.03. What is the difference between the Expenses (% of total expenses) of Goods and services and Expenses (% of total expenses) of Other expenses in Congo (Republic)?
Give a very brief answer. 18.42. What is the difference between the Expenses (% of total expenses) in Subsidies and Transfers and Expenses (% of total expenses) in Other expenses in Congo (Republic)?
Your answer should be compact. 18.45. What is the ratio of the Expenses (% of total expenses) of Compensation of employees in Cambodia to that in Canada?
Give a very brief answer. 3.06. What is the ratio of the Expenses (% of total expenses) in Goods and services in Cambodia to that in Canada?
Keep it short and to the point. 5.97. What is the ratio of the Expenses (% of total expenses) in Subsidies and Transfers in Cambodia to that in Canada?
Offer a very short reply. 48.27. What is the ratio of the Expenses (% of total expenses) of Other expenses in Cambodia to that in Canada?
Your answer should be very brief. 3.7. What is the ratio of the Expenses (% of total expenses) in Compensation of employees in Cambodia to that in Chile?
Keep it short and to the point. 1.71. What is the ratio of the Expenses (% of total expenses) in Goods and services in Cambodia to that in Chile?
Give a very brief answer. 5.25. What is the ratio of the Expenses (% of total expenses) of Subsidies and Transfers in Cambodia to that in Chile?
Your answer should be compact. 8.26. What is the ratio of the Expenses (% of total expenses) in Other expenses in Cambodia to that in Chile?
Make the answer very short. 0.48. What is the ratio of the Expenses (% of total expenses) in Compensation of employees in Cambodia to that in Colombia?
Keep it short and to the point. 1.77. What is the ratio of the Expenses (% of total expenses) of Goods and services in Cambodia to that in Colombia?
Offer a very short reply. 4.75. What is the ratio of the Expenses (% of total expenses) in Subsidies and Transfers in Cambodia to that in Colombia?
Offer a terse response. 5.14. What is the ratio of the Expenses (% of total expenses) of Other expenses in Cambodia to that in Colombia?
Offer a very short reply. 0.39. What is the ratio of the Expenses (% of total expenses) in Compensation of employees in Cambodia to that in Congo (Democratic)?
Your answer should be compact. 1.74. What is the ratio of the Expenses (% of total expenses) in Goods and services in Cambodia to that in Congo (Democratic)?
Offer a very short reply. 0.78. What is the ratio of the Expenses (% of total expenses) of Subsidies and Transfers in Cambodia to that in Congo (Democratic)?
Ensure brevity in your answer.  0.76. What is the ratio of the Expenses (% of total expenses) of Other expenses in Cambodia to that in Congo (Democratic)?
Your answer should be compact. 2.4. What is the ratio of the Expenses (% of total expenses) in Compensation of employees in Cambodia to that in Congo (Republic)?
Your response must be concise. 0.97. What is the ratio of the Expenses (% of total expenses) of Goods and services in Cambodia to that in Congo (Republic)?
Offer a very short reply. 1.47. What is the ratio of the Expenses (% of total expenses) in Subsidies and Transfers in Cambodia to that in Congo (Republic)?
Provide a short and direct response. 1.42. What is the ratio of the Expenses (% of total expenses) in Other expenses in Cambodia to that in Congo (Republic)?
Your answer should be very brief. 0.82. What is the ratio of the Expenses (% of total expenses) of Compensation of employees in Canada to that in Chile?
Make the answer very short. 0.56. What is the ratio of the Expenses (% of total expenses) in Goods and services in Canada to that in Chile?
Provide a short and direct response. 0.88. What is the ratio of the Expenses (% of total expenses) of Subsidies and Transfers in Canada to that in Chile?
Your answer should be compact. 0.17. What is the ratio of the Expenses (% of total expenses) of Other expenses in Canada to that in Chile?
Ensure brevity in your answer.  0.13. What is the ratio of the Expenses (% of total expenses) in Compensation of employees in Canada to that in Colombia?
Provide a succinct answer. 0.58. What is the ratio of the Expenses (% of total expenses) in Goods and services in Canada to that in Colombia?
Offer a terse response. 0.79. What is the ratio of the Expenses (% of total expenses) of Subsidies and Transfers in Canada to that in Colombia?
Provide a short and direct response. 0.11. What is the ratio of the Expenses (% of total expenses) of Other expenses in Canada to that in Colombia?
Keep it short and to the point. 0.11. What is the ratio of the Expenses (% of total expenses) of Compensation of employees in Canada to that in Congo (Democratic)?
Your response must be concise. 0.57. What is the ratio of the Expenses (% of total expenses) of Goods and services in Canada to that in Congo (Democratic)?
Your answer should be very brief. 0.13. What is the ratio of the Expenses (% of total expenses) in Subsidies and Transfers in Canada to that in Congo (Democratic)?
Keep it short and to the point. 0.02. What is the ratio of the Expenses (% of total expenses) of Other expenses in Canada to that in Congo (Democratic)?
Make the answer very short. 0.65. What is the ratio of the Expenses (% of total expenses) in Compensation of employees in Canada to that in Congo (Republic)?
Provide a short and direct response. 0.32. What is the ratio of the Expenses (% of total expenses) of Goods and services in Canada to that in Congo (Republic)?
Keep it short and to the point. 0.25. What is the ratio of the Expenses (% of total expenses) of Subsidies and Transfers in Canada to that in Congo (Republic)?
Ensure brevity in your answer.  0.03. What is the ratio of the Expenses (% of total expenses) of Other expenses in Canada to that in Congo (Republic)?
Give a very brief answer. 0.22. What is the ratio of the Expenses (% of total expenses) in Compensation of employees in Chile to that in Colombia?
Offer a terse response. 1.03. What is the ratio of the Expenses (% of total expenses) in Goods and services in Chile to that in Colombia?
Keep it short and to the point. 0.9. What is the ratio of the Expenses (% of total expenses) of Subsidies and Transfers in Chile to that in Colombia?
Your answer should be compact. 0.62. What is the ratio of the Expenses (% of total expenses) in Other expenses in Chile to that in Colombia?
Make the answer very short. 0.82. What is the ratio of the Expenses (% of total expenses) of Compensation of employees in Chile to that in Congo (Democratic)?
Your response must be concise. 1.02. What is the ratio of the Expenses (% of total expenses) in Goods and services in Chile to that in Congo (Democratic)?
Offer a terse response. 0.15. What is the ratio of the Expenses (% of total expenses) in Subsidies and Transfers in Chile to that in Congo (Democratic)?
Your answer should be compact. 0.09. What is the ratio of the Expenses (% of total expenses) of Other expenses in Chile to that in Congo (Democratic)?
Make the answer very short. 4.99. What is the ratio of the Expenses (% of total expenses) in Compensation of employees in Chile to that in Congo (Republic)?
Provide a short and direct response. 0.56. What is the ratio of the Expenses (% of total expenses) of Goods and services in Chile to that in Congo (Republic)?
Make the answer very short. 0.28. What is the ratio of the Expenses (% of total expenses) of Subsidies and Transfers in Chile to that in Congo (Republic)?
Provide a succinct answer. 0.17. What is the ratio of the Expenses (% of total expenses) in Other expenses in Chile to that in Congo (Republic)?
Provide a succinct answer. 1.7. What is the ratio of the Expenses (% of total expenses) in Compensation of employees in Colombia to that in Congo (Democratic)?
Ensure brevity in your answer.  0.99. What is the ratio of the Expenses (% of total expenses) of Goods and services in Colombia to that in Congo (Democratic)?
Offer a very short reply. 0.16. What is the ratio of the Expenses (% of total expenses) in Subsidies and Transfers in Colombia to that in Congo (Democratic)?
Offer a very short reply. 0.15. What is the ratio of the Expenses (% of total expenses) in Other expenses in Colombia to that in Congo (Democratic)?
Provide a succinct answer. 6.08. What is the ratio of the Expenses (% of total expenses) of Compensation of employees in Colombia to that in Congo (Republic)?
Make the answer very short. 0.55. What is the ratio of the Expenses (% of total expenses) in Goods and services in Colombia to that in Congo (Republic)?
Provide a succinct answer. 0.31. What is the ratio of the Expenses (% of total expenses) in Subsidies and Transfers in Colombia to that in Congo (Republic)?
Provide a short and direct response. 0.28. What is the ratio of the Expenses (% of total expenses) in Other expenses in Colombia to that in Congo (Republic)?
Your answer should be compact. 2.07. What is the ratio of the Expenses (% of total expenses) in Compensation of employees in Congo (Democratic) to that in Congo (Republic)?
Your answer should be very brief. 0.55. What is the ratio of the Expenses (% of total expenses) in Goods and services in Congo (Democratic) to that in Congo (Republic)?
Your answer should be very brief. 1.89. What is the ratio of the Expenses (% of total expenses) of Subsidies and Transfers in Congo (Democratic) to that in Congo (Republic)?
Your answer should be compact. 1.87. What is the ratio of the Expenses (% of total expenses) in Other expenses in Congo (Democratic) to that in Congo (Republic)?
Your response must be concise. 0.34. What is the difference between the highest and the second highest Expenses (% of total expenses) in Compensation of employees?
Keep it short and to the point. 1.27. What is the difference between the highest and the second highest Expenses (% of total expenses) of Goods and services?
Make the answer very short. 12.15. What is the difference between the highest and the second highest Expenses (% of total expenses) in Subsidies and Transfers?
Your answer should be compact. 13.29. What is the difference between the highest and the second highest Expenses (% of total expenses) in Other expenses?
Keep it short and to the point. 3.96. What is the difference between the highest and the lowest Expenses (% of total expenses) of Compensation of employees?
Ensure brevity in your answer.  25.31. What is the difference between the highest and the lowest Expenses (% of total expenses) of Goods and services?
Ensure brevity in your answer.  47.72. What is the difference between the highest and the lowest Expenses (% of total expenses) in Subsidies and Transfers?
Offer a very short reply. 53.62. What is the difference between the highest and the lowest Expenses (% of total expenses) in Other expenses?
Offer a very short reply. 19.61. 